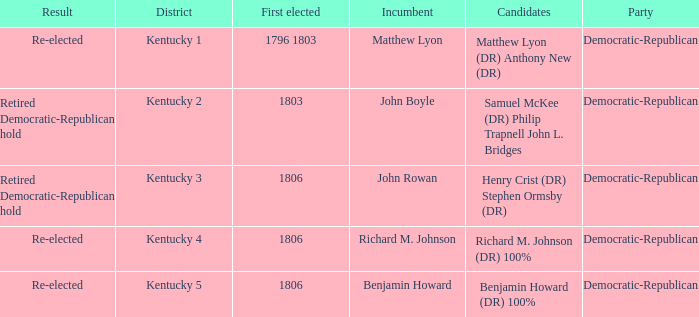Name the first elected for kentucky 3 1806.0. 